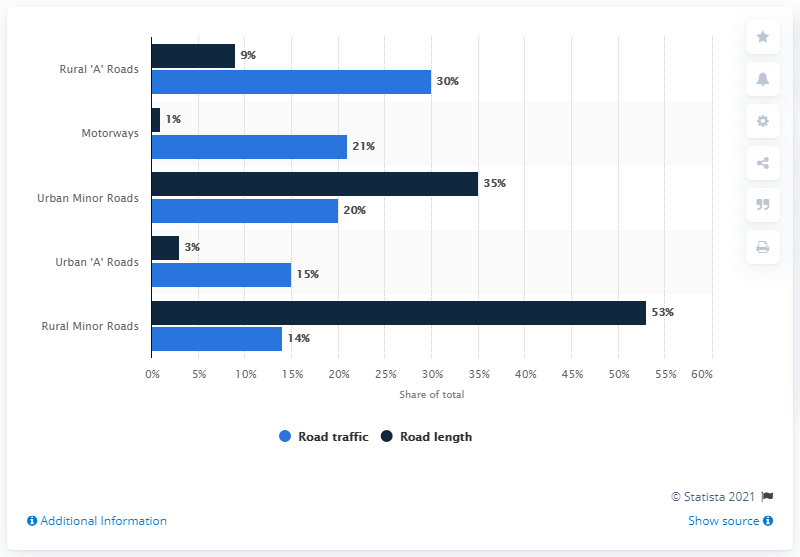List a handful of essential elements in this visual. In rural areas, a significant portion of road traffic is carried by minor roads. Specifically, it was found that approximately 14% of road traffic is carried by rural minor roads. This statistic compares the lengths of roads in the UK in 2017 across different types of roads. It is estimated that motorways in the UK make up approximately 10% of the total road network. 